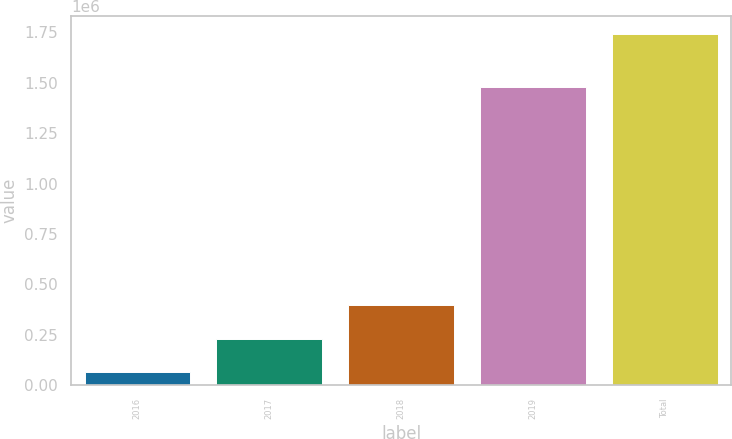<chart> <loc_0><loc_0><loc_500><loc_500><bar_chart><fcel>2016<fcel>2017<fcel>2018<fcel>2019<fcel>Total<nl><fcel>62500<fcel>230500<fcel>398500<fcel>1.47688e+06<fcel>1.7425e+06<nl></chart> 